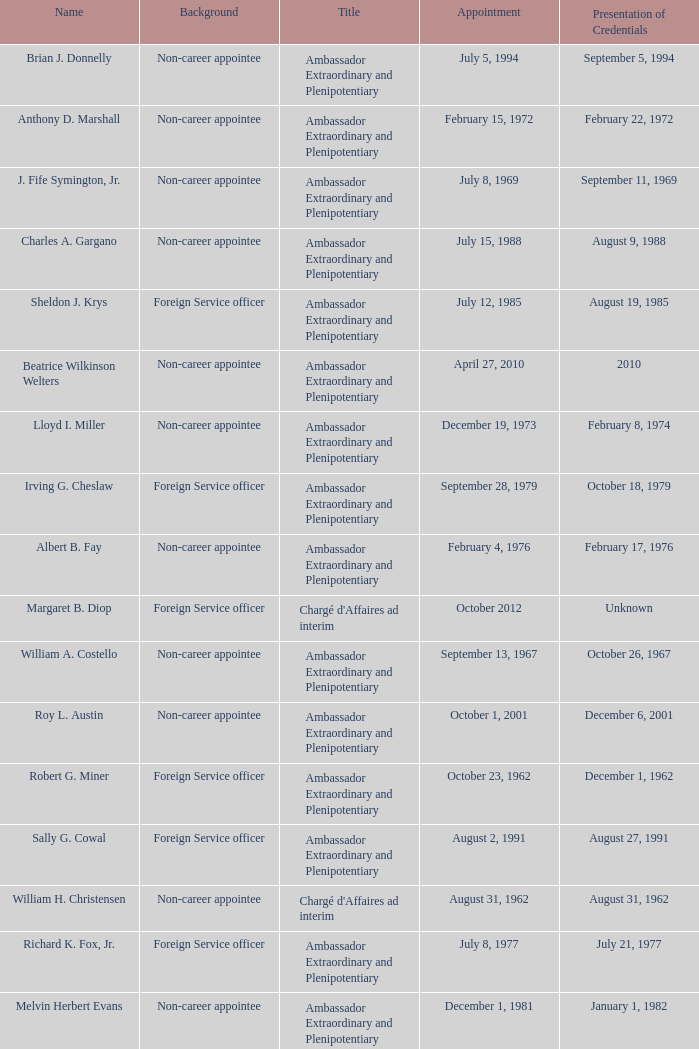When did Robert G. Miner present his credentials? December 1, 1962. 